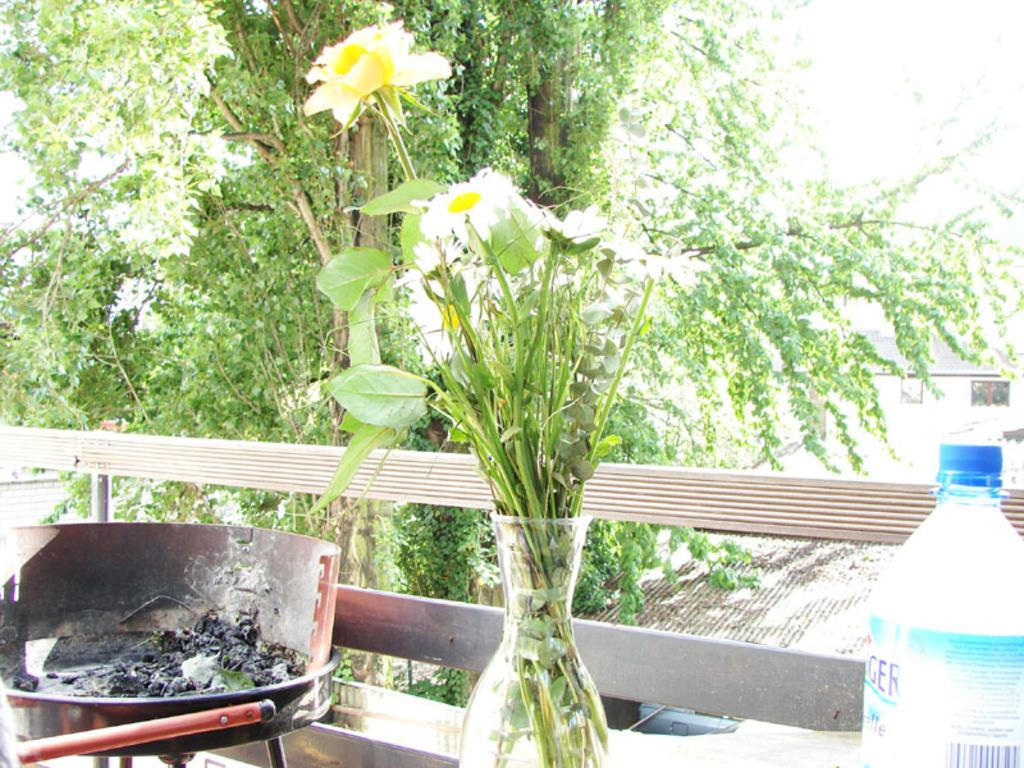What is in the vase that is visible in the image? There is a vase with white flowers and leaves in the image. What other objects can be seen in the image? There is a bottle and a coal burning in a tray visible in the image. What can be seen in the background of the image? There are trees visible in the background of the image. What type of sticks are used to create the verse in the image? There are no sticks or verses present in the image. 